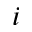<formula> <loc_0><loc_0><loc_500><loc_500>i</formula> 